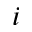<formula> <loc_0><loc_0><loc_500><loc_500>i</formula> 